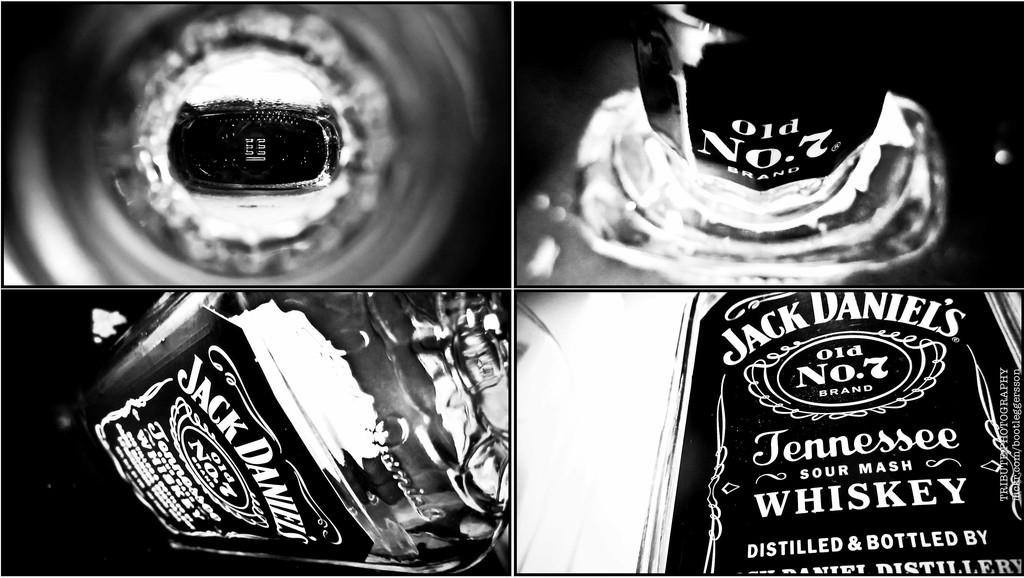What is the main object in the image? There is a wine bottle in the image. Can you describe the composition of the image? The image is a collage edited image. How many nails are used to hold the quilt in the image? There is no quilt or nails present in the image. What type of kitten can be seen playing with the wine bottle in the image? There is no kitten present in the image, and the wine bottle is not being played with. 